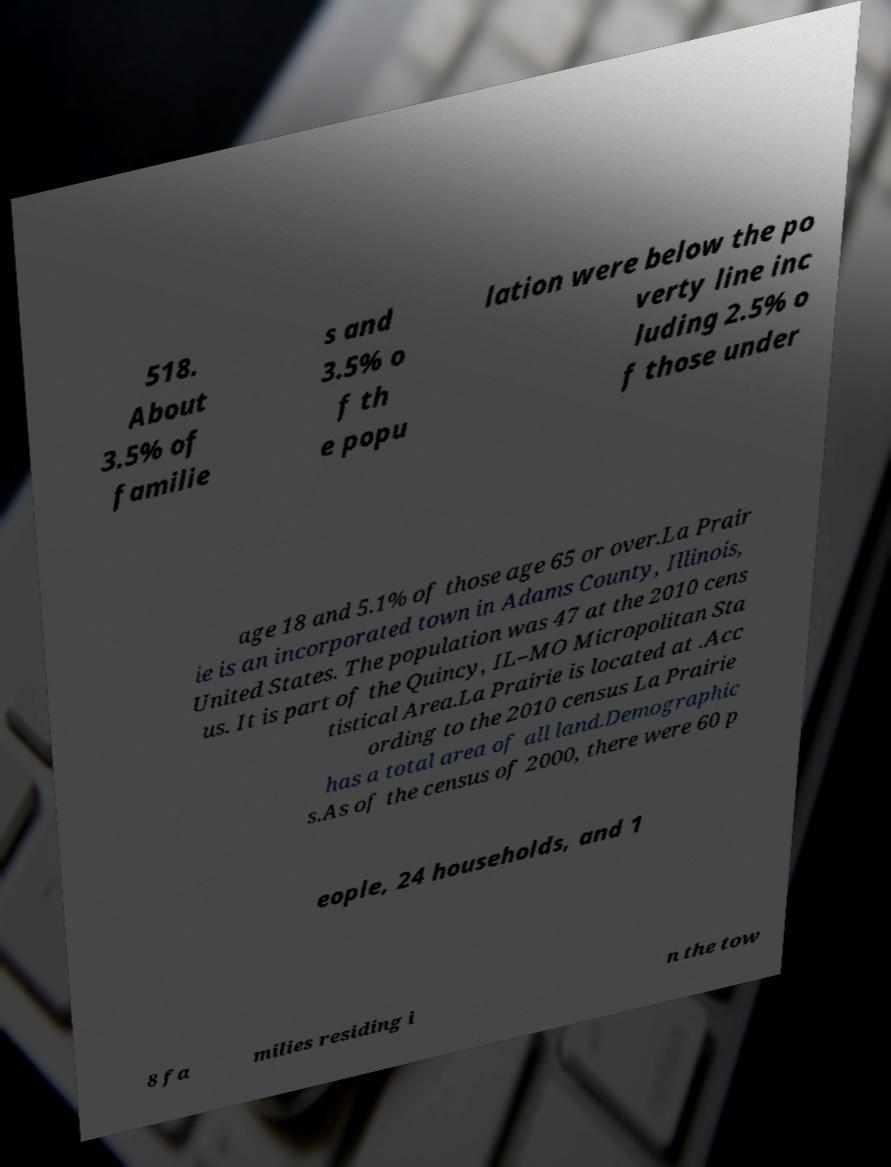There's text embedded in this image that I need extracted. Can you transcribe it verbatim? 518. About 3.5% of familie s and 3.5% o f th e popu lation were below the po verty line inc luding 2.5% o f those under age 18 and 5.1% of those age 65 or over.La Prair ie is an incorporated town in Adams County, Illinois, United States. The population was 47 at the 2010 cens us. It is part of the Quincy, IL–MO Micropolitan Sta tistical Area.La Prairie is located at .Acc ording to the 2010 census La Prairie has a total area of all land.Demographic s.As of the census of 2000, there were 60 p eople, 24 households, and 1 8 fa milies residing i n the tow 